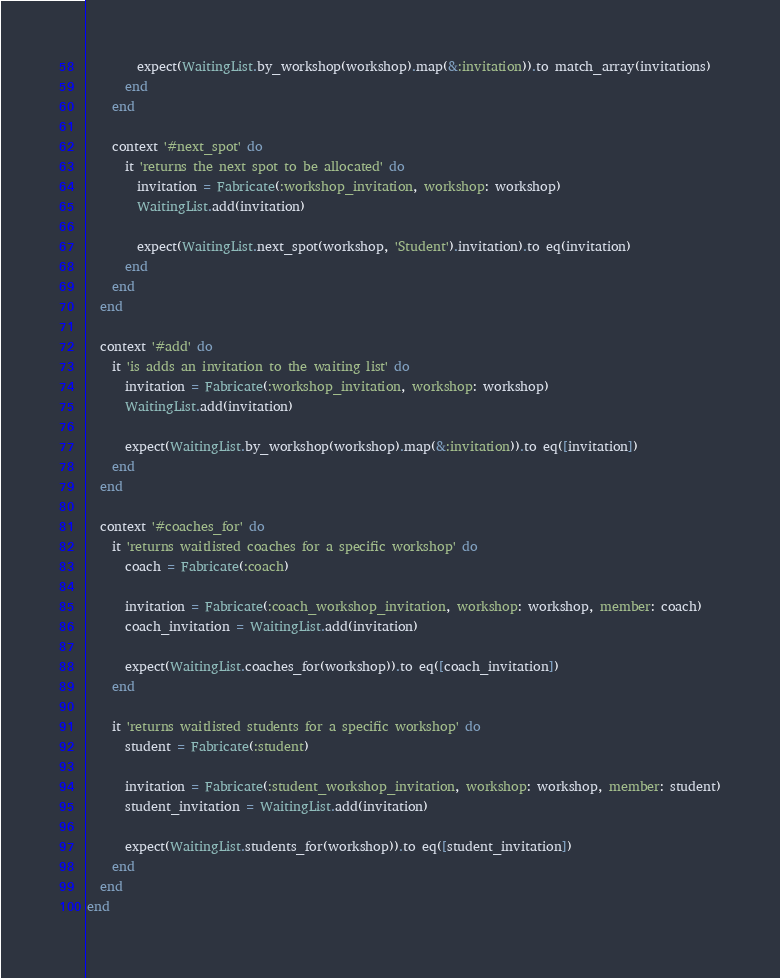Convert code to text. <code><loc_0><loc_0><loc_500><loc_500><_Ruby_>
        expect(WaitingList.by_workshop(workshop).map(&:invitation)).to match_array(invitations)
      end
    end

    context '#next_spot' do
      it 'returns the next spot to be allocated' do
        invitation = Fabricate(:workshop_invitation, workshop: workshop)
        WaitingList.add(invitation)

        expect(WaitingList.next_spot(workshop, 'Student').invitation).to eq(invitation)
      end
    end
  end

  context '#add' do
    it 'is adds an invitation to the waiting list' do
      invitation = Fabricate(:workshop_invitation, workshop: workshop)
      WaitingList.add(invitation)

      expect(WaitingList.by_workshop(workshop).map(&:invitation)).to eq([invitation])
    end
  end

  context '#coaches_for' do
    it 'returns waitlisted coaches for a specific workshop' do
      coach = Fabricate(:coach)

      invitation = Fabricate(:coach_workshop_invitation, workshop: workshop, member: coach)
      coach_invitation = WaitingList.add(invitation)

      expect(WaitingList.coaches_for(workshop)).to eq([coach_invitation])
    end

    it 'returns waitlisted students for a specific workshop' do
      student = Fabricate(:student)
      
      invitation = Fabricate(:student_workshop_invitation, workshop: workshop, member: student)
      student_invitation = WaitingList.add(invitation)

      expect(WaitingList.students_for(workshop)).to eq([student_invitation])
    end
  end
end
</code> 